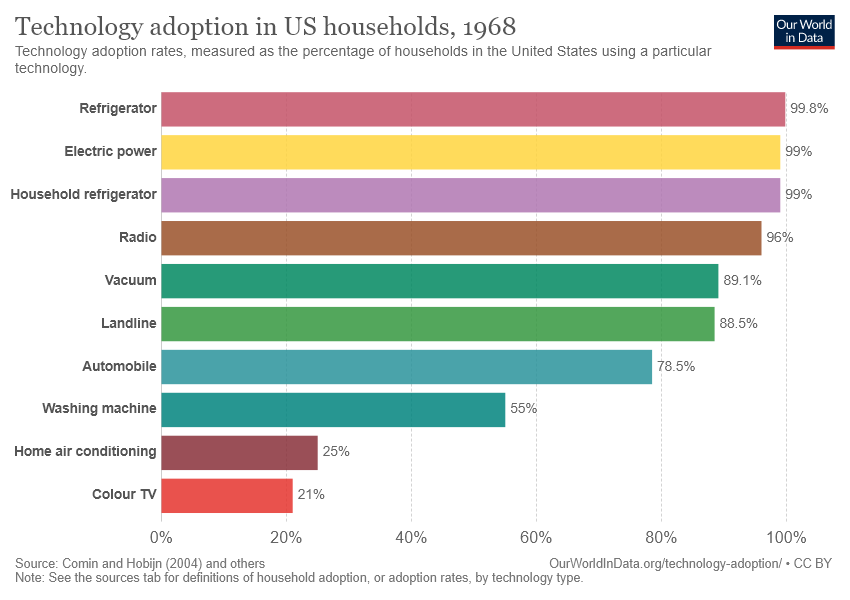List a handful of essential elements in this visual. The red bar represents the concept of color television. The value of a radio is different from that of a color TV, with a difference of 75... 